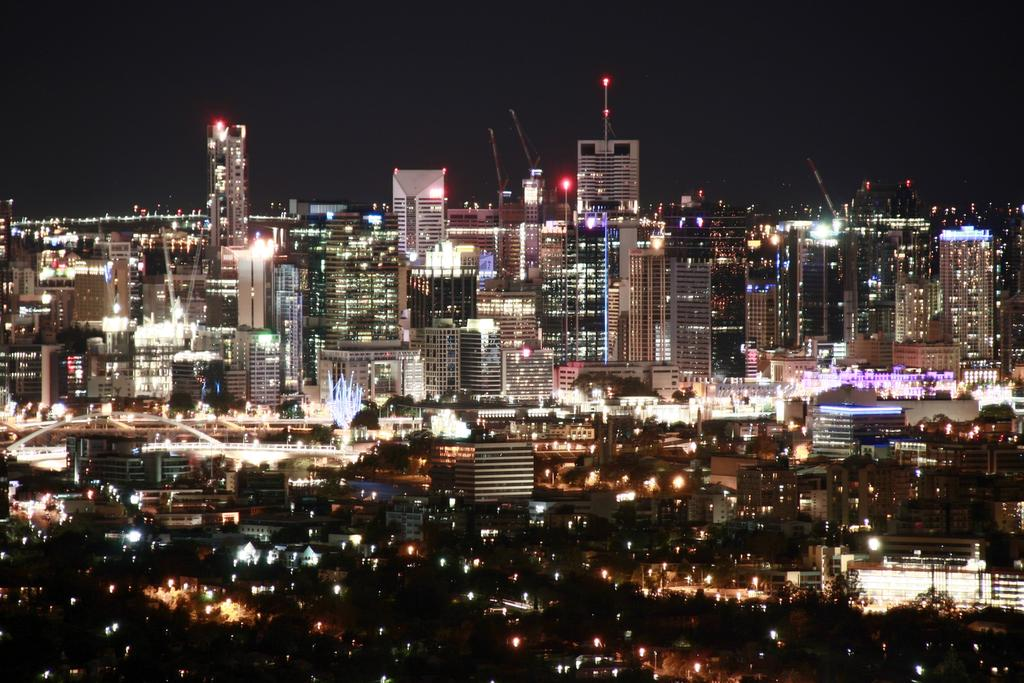What type of view is shown in the image? The image is an aerial view of a city. When was the image taken? The image was taken at night time. What can be seen on the buildings in the image? There are lights visible on the buildings in the image. What type of bottle is visible on the sidewalk in the image? There is no bottle or sidewalk present in the image, as it is an aerial view of a city at night. 